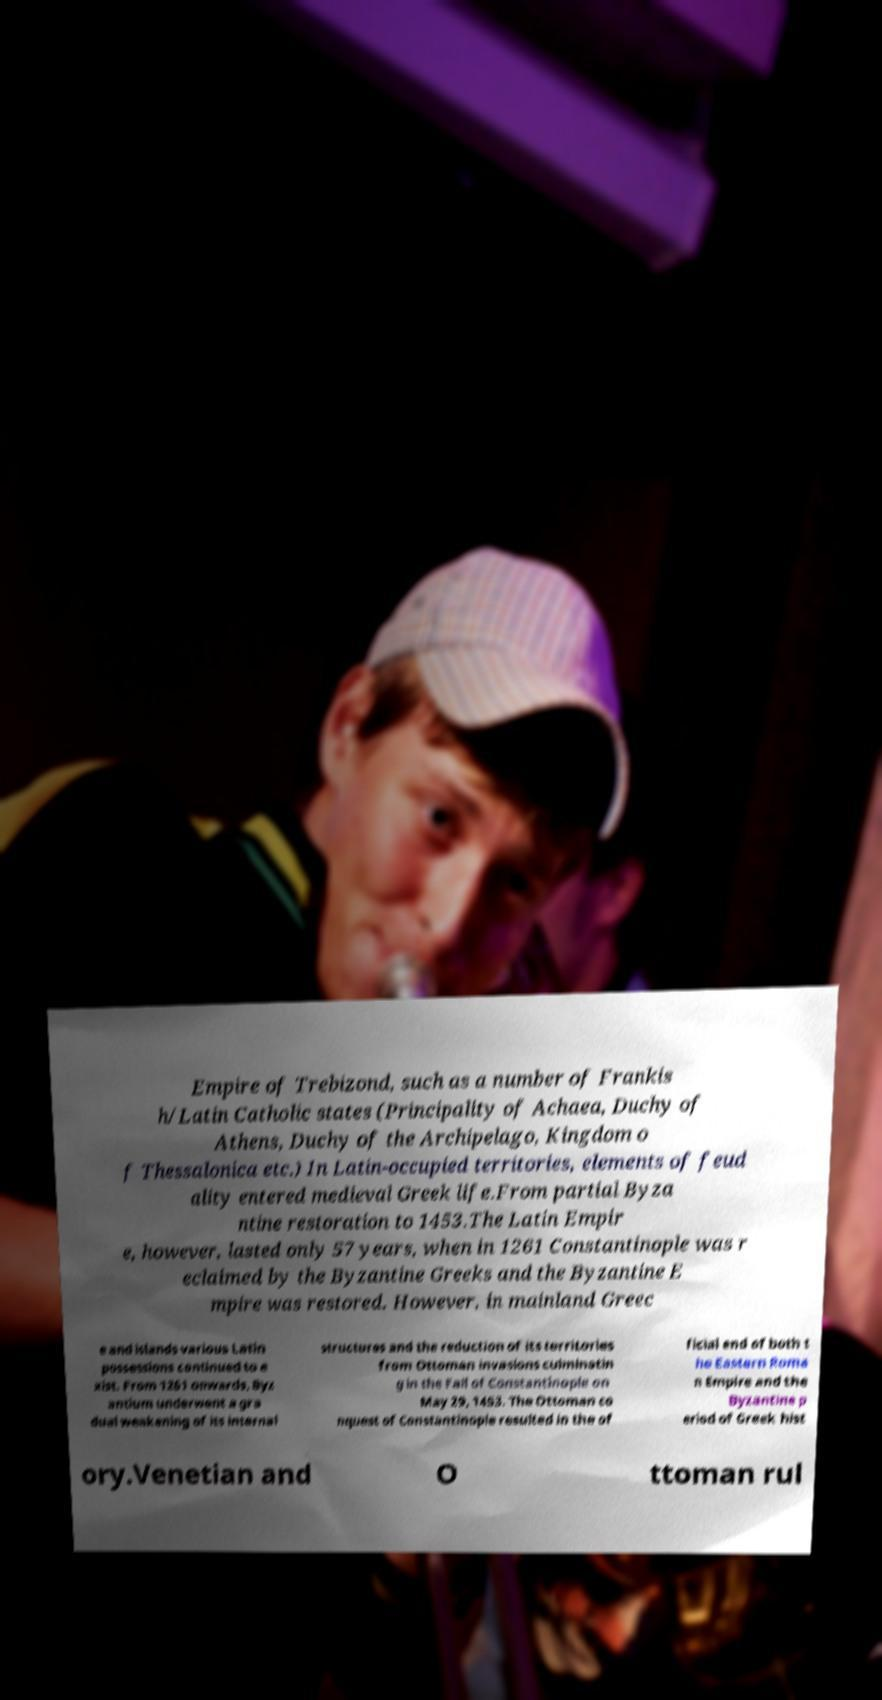Could you assist in decoding the text presented in this image and type it out clearly? Empire of Trebizond, such as a number of Frankis h/Latin Catholic states (Principality of Achaea, Duchy of Athens, Duchy of the Archipelago, Kingdom o f Thessalonica etc.) In Latin-occupied territories, elements of feud ality entered medieval Greek life.From partial Byza ntine restoration to 1453.The Latin Empir e, however, lasted only 57 years, when in 1261 Constantinople was r eclaimed by the Byzantine Greeks and the Byzantine E mpire was restored. However, in mainland Greec e and islands various Latin possessions continued to e xist. From 1261 onwards, Byz antium underwent a gra dual weakening of its internal structures and the reduction of its territories from Ottoman invasions culminatin g in the Fall of Constantinople on May 29, 1453. The Ottoman co nquest of Constantinople resulted in the of ficial end of both t he Eastern Roma n Empire and the Byzantine p eriod of Greek hist ory.Venetian and O ttoman rul 